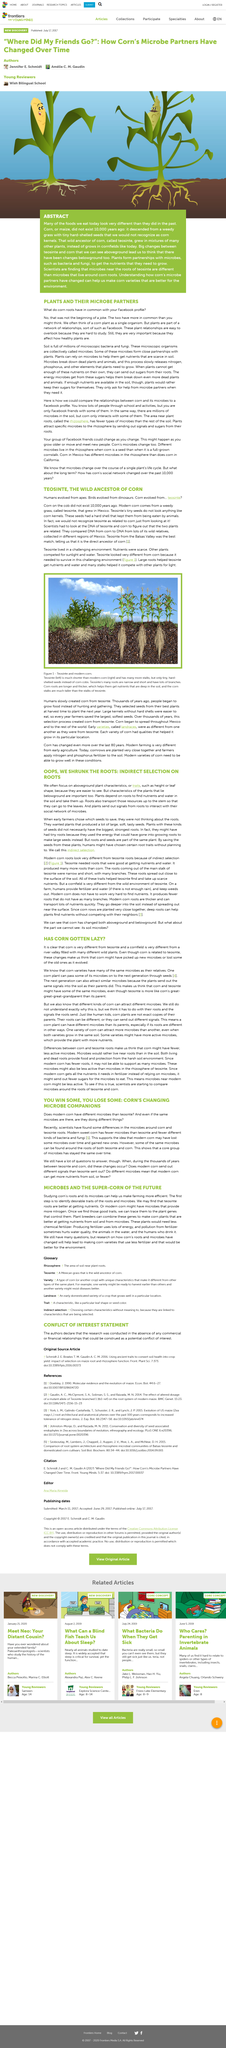Outline some significant characteristics in this image. Corn plants are similar to Facebook because they both have a network of relationships and connections. It is often the case that we focus on above-ground plant characteristics because they are easier to observe and observe. It is important to conduct research on the characteristics of below-ground plants because they play a vital role in a plant's ability to access nutrients and water in the soil, which is essential for its survival and growth. Microbes play a crucial role in the health of plants. They can either positively or negatively affect the growth and development of plants, depending on the type and abundance of microbes present. In particular, microbes can influence the immune systems of plants, affecting their overall health and resistance to disease. Scientists have compared corn and other plants by analyzing their DNA sequences. 